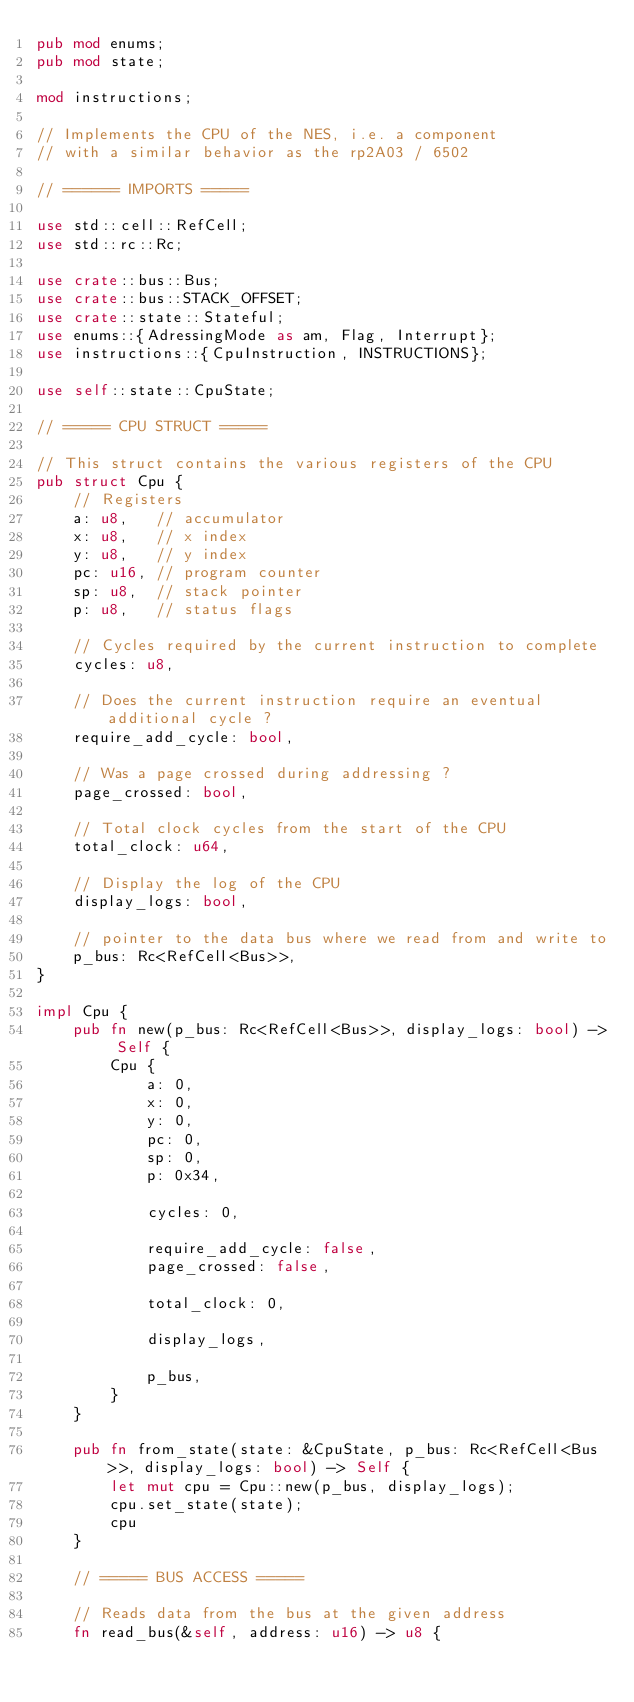Convert code to text. <code><loc_0><loc_0><loc_500><loc_500><_Rust_>pub mod enums;
pub mod state;

mod instructions;

// Implements the CPU of the NES, i.e. a component
// with a similar behavior as the rp2A03 / 6502

// ====== IMPORTS =====

use std::cell::RefCell;
use std::rc::Rc;

use crate::bus::Bus;
use crate::bus::STACK_OFFSET;
use crate::state::Stateful;
use enums::{AdressingMode as am, Flag, Interrupt};
use instructions::{CpuInstruction, INSTRUCTIONS};

use self::state::CpuState;

// ===== CPU STRUCT =====

// This struct contains the various registers of the CPU
pub struct Cpu {
    // Registers
    a: u8,   // accumulator
    x: u8,   // x index
    y: u8,   // y index
    pc: u16, // program counter
    sp: u8,  // stack pointer
    p: u8,   // status flags

    // Cycles required by the current instruction to complete
    cycles: u8,

    // Does the current instruction require an eventual additional cycle ?
    require_add_cycle: bool,

    // Was a page crossed during addressing ?
    page_crossed: bool,

    // Total clock cycles from the start of the CPU
    total_clock: u64,

    // Display the log of the CPU
    display_logs: bool,

    // pointer to the data bus where we read from and write to
    p_bus: Rc<RefCell<Bus>>,
}

impl Cpu {
    pub fn new(p_bus: Rc<RefCell<Bus>>, display_logs: bool) -> Self {
        Cpu {
            a: 0,
            x: 0,
            y: 0,
            pc: 0,
            sp: 0,
            p: 0x34,

            cycles: 0,

            require_add_cycle: false,
            page_crossed: false,

            total_clock: 0,

            display_logs,

            p_bus,
        }
    }

    pub fn from_state(state: &CpuState, p_bus: Rc<RefCell<Bus>>, display_logs: bool) -> Self {
        let mut cpu = Cpu::new(p_bus, display_logs);
        cpu.set_state(state);
        cpu
    }

    // ===== BUS ACCESS =====

    // Reads data from the bus at the given address
    fn read_bus(&self, address: u16) -> u8 {</code> 